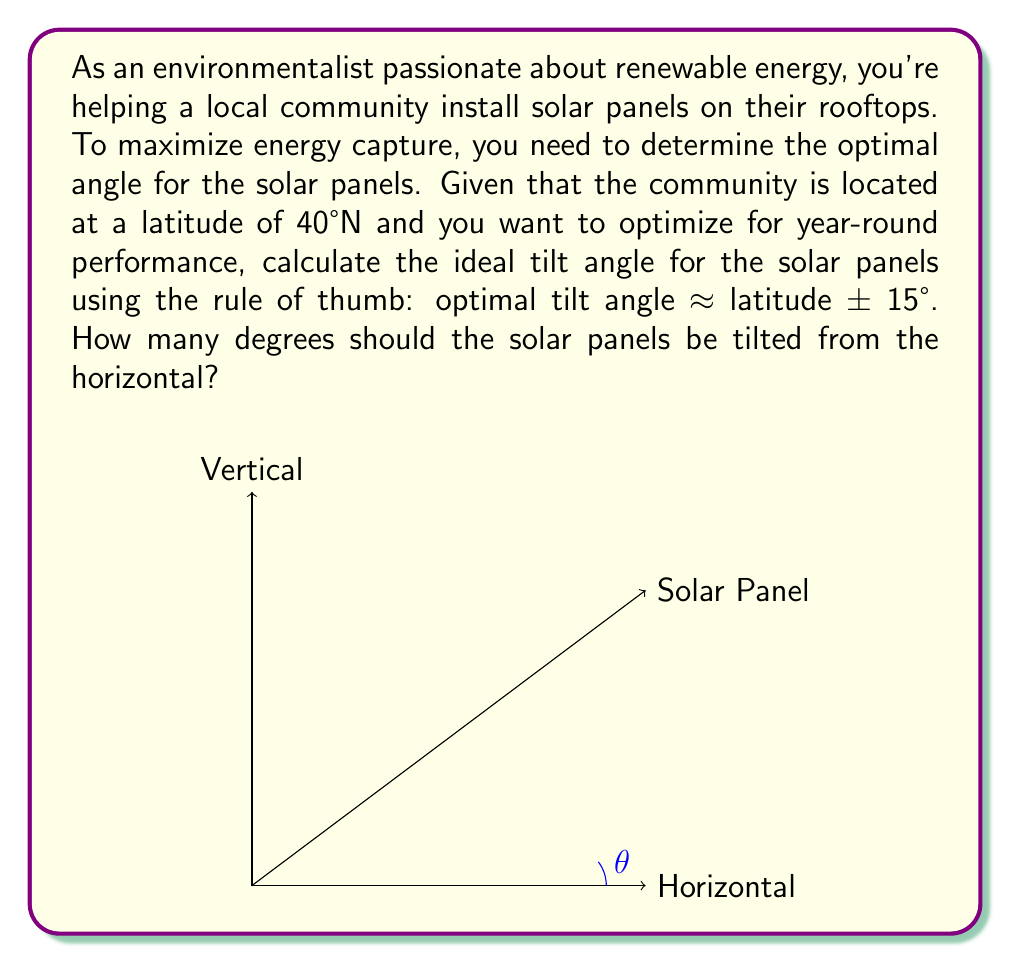Could you help me with this problem? Let's approach this step-by-step:

1) The rule of thumb for optimal solar panel tilt is:

   $$ \text{Optimal Tilt} \approx \text{Latitude} \pm 15° $$

2) In this case, we're given a latitude of 40°N. Since we want to optimize for year-round performance, we'll use the latitude without adding or subtracting 15°.

3) Therefore, the optimal tilt angle is approximately equal to the latitude:

   $$ \text{Optimal Tilt} \approx 40° $$

4) This means the solar panels should be tilted 40° from the horizontal.

5) To visualize this, imagine a right triangle where:
   - The hypotenuse represents the solar panel
   - The angle between the horizontal and the panel is 40°
   - The vertical side represents the height of the panel's top edge

6) Using trigonometry, we can confirm that this angle maximizes the panel's exposure to sunlight throughout the year, balancing between summer and winter sun positions.

This solution is both environmentally friendly and optimistic, as it helps the community maximize their solar energy capture year-round!
Answer: The solar panels should be tilted approximately 40° from the horizontal. 